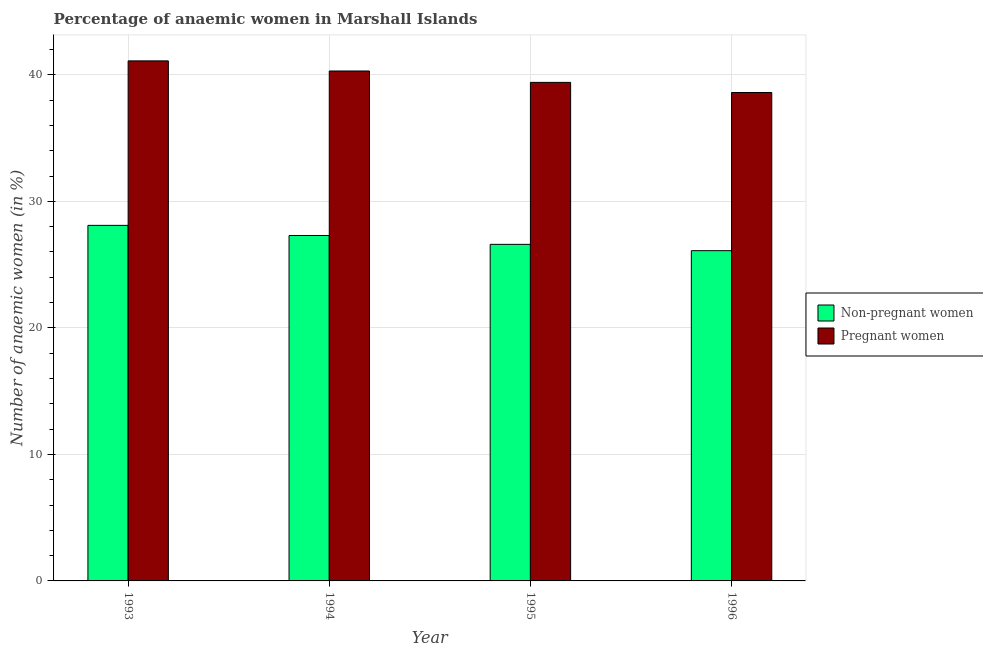Are the number of bars per tick equal to the number of legend labels?
Ensure brevity in your answer.  Yes. Are the number of bars on each tick of the X-axis equal?
Keep it short and to the point. Yes. How many bars are there on the 3rd tick from the left?
Offer a very short reply. 2. What is the label of the 3rd group of bars from the left?
Your response must be concise. 1995. In how many cases, is the number of bars for a given year not equal to the number of legend labels?
Provide a short and direct response. 0. What is the percentage of non-pregnant anaemic women in 1996?
Your answer should be compact. 26.1. Across all years, what is the maximum percentage of pregnant anaemic women?
Provide a succinct answer. 41.1. Across all years, what is the minimum percentage of non-pregnant anaemic women?
Provide a short and direct response. 26.1. What is the total percentage of pregnant anaemic women in the graph?
Provide a short and direct response. 159.4. What is the difference between the percentage of non-pregnant anaemic women in 1994 and that in 1995?
Make the answer very short. 0.7. What is the average percentage of non-pregnant anaemic women per year?
Give a very brief answer. 27.02. In how many years, is the percentage of pregnant anaemic women greater than 6 %?
Provide a short and direct response. 4. What is the ratio of the percentage of pregnant anaemic women in 1993 to that in 1994?
Your answer should be very brief. 1.02. Is the difference between the percentage of non-pregnant anaemic women in 1993 and 1994 greater than the difference between the percentage of pregnant anaemic women in 1993 and 1994?
Ensure brevity in your answer.  No. What is the difference between the highest and the second highest percentage of non-pregnant anaemic women?
Your response must be concise. 0.8. What is the difference between the highest and the lowest percentage of pregnant anaemic women?
Your response must be concise. 2.5. In how many years, is the percentage of pregnant anaemic women greater than the average percentage of pregnant anaemic women taken over all years?
Your answer should be compact. 2. Is the sum of the percentage of pregnant anaemic women in 1994 and 1995 greater than the maximum percentage of non-pregnant anaemic women across all years?
Your response must be concise. Yes. What does the 1st bar from the left in 1993 represents?
Provide a succinct answer. Non-pregnant women. What does the 2nd bar from the right in 1993 represents?
Provide a short and direct response. Non-pregnant women. How many years are there in the graph?
Provide a succinct answer. 4. Are the values on the major ticks of Y-axis written in scientific E-notation?
Provide a succinct answer. No. Does the graph contain grids?
Your answer should be compact. Yes. What is the title of the graph?
Offer a very short reply. Percentage of anaemic women in Marshall Islands. What is the label or title of the Y-axis?
Your response must be concise. Number of anaemic women (in %). What is the Number of anaemic women (in %) of Non-pregnant women in 1993?
Give a very brief answer. 28.1. What is the Number of anaemic women (in %) in Pregnant women in 1993?
Offer a terse response. 41.1. What is the Number of anaemic women (in %) in Non-pregnant women in 1994?
Offer a terse response. 27.3. What is the Number of anaemic women (in %) of Pregnant women in 1994?
Keep it short and to the point. 40.3. What is the Number of anaemic women (in %) of Non-pregnant women in 1995?
Give a very brief answer. 26.6. What is the Number of anaemic women (in %) in Pregnant women in 1995?
Provide a short and direct response. 39.4. What is the Number of anaemic women (in %) in Non-pregnant women in 1996?
Keep it short and to the point. 26.1. What is the Number of anaemic women (in %) of Pregnant women in 1996?
Offer a terse response. 38.6. Across all years, what is the maximum Number of anaemic women (in %) in Non-pregnant women?
Your answer should be very brief. 28.1. Across all years, what is the maximum Number of anaemic women (in %) of Pregnant women?
Your answer should be compact. 41.1. Across all years, what is the minimum Number of anaemic women (in %) of Non-pregnant women?
Your answer should be compact. 26.1. Across all years, what is the minimum Number of anaemic women (in %) in Pregnant women?
Your answer should be very brief. 38.6. What is the total Number of anaemic women (in %) in Non-pregnant women in the graph?
Offer a terse response. 108.1. What is the total Number of anaemic women (in %) in Pregnant women in the graph?
Provide a short and direct response. 159.4. What is the difference between the Number of anaemic women (in %) in Non-pregnant women in 1993 and that in 1994?
Give a very brief answer. 0.8. What is the difference between the Number of anaemic women (in %) of Pregnant women in 1993 and that in 1994?
Your answer should be compact. 0.8. What is the difference between the Number of anaemic women (in %) of Non-pregnant women in 1993 and that in 1996?
Offer a terse response. 2. What is the difference between the Number of anaemic women (in %) of Non-pregnant women in 1995 and that in 1996?
Keep it short and to the point. 0.5. What is the difference between the Number of anaemic women (in %) of Non-pregnant women in 1993 and the Number of anaemic women (in %) of Pregnant women in 1995?
Your response must be concise. -11.3. What is the difference between the Number of anaemic women (in %) in Non-pregnant women in 1994 and the Number of anaemic women (in %) in Pregnant women in 1995?
Your answer should be very brief. -12.1. What is the difference between the Number of anaemic women (in %) in Non-pregnant women in 1994 and the Number of anaemic women (in %) in Pregnant women in 1996?
Offer a terse response. -11.3. What is the average Number of anaemic women (in %) in Non-pregnant women per year?
Ensure brevity in your answer.  27.02. What is the average Number of anaemic women (in %) of Pregnant women per year?
Offer a terse response. 39.85. In the year 1993, what is the difference between the Number of anaemic women (in %) of Non-pregnant women and Number of anaemic women (in %) of Pregnant women?
Your answer should be very brief. -13. In the year 1994, what is the difference between the Number of anaemic women (in %) of Non-pregnant women and Number of anaemic women (in %) of Pregnant women?
Ensure brevity in your answer.  -13. In the year 1995, what is the difference between the Number of anaemic women (in %) of Non-pregnant women and Number of anaemic women (in %) of Pregnant women?
Ensure brevity in your answer.  -12.8. What is the ratio of the Number of anaemic women (in %) in Non-pregnant women in 1993 to that in 1994?
Provide a short and direct response. 1.03. What is the ratio of the Number of anaemic women (in %) of Pregnant women in 1993 to that in 1994?
Your answer should be very brief. 1.02. What is the ratio of the Number of anaemic women (in %) of Non-pregnant women in 1993 to that in 1995?
Your answer should be very brief. 1.06. What is the ratio of the Number of anaemic women (in %) of Pregnant women in 1993 to that in 1995?
Your answer should be compact. 1.04. What is the ratio of the Number of anaemic women (in %) in Non-pregnant women in 1993 to that in 1996?
Offer a very short reply. 1.08. What is the ratio of the Number of anaemic women (in %) in Pregnant women in 1993 to that in 1996?
Your answer should be very brief. 1.06. What is the ratio of the Number of anaemic women (in %) in Non-pregnant women in 1994 to that in 1995?
Your answer should be compact. 1.03. What is the ratio of the Number of anaemic women (in %) in Pregnant women in 1994 to that in 1995?
Make the answer very short. 1.02. What is the ratio of the Number of anaemic women (in %) of Non-pregnant women in 1994 to that in 1996?
Keep it short and to the point. 1.05. What is the ratio of the Number of anaemic women (in %) of Pregnant women in 1994 to that in 1996?
Provide a succinct answer. 1.04. What is the ratio of the Number of anaemic women (in %) in Non-pregnant women in 1995 to that in 1996?
Provide a succinct answer. 1.02. What is the ratio of the Number of anaemic women (in %) in Pregnant women in 1995 to that in 1996?
Give a very brief answer. 1.02. What is the difference between the highest and the second highest Number of anaemic women (in %) of Non-pregnant women?
Give a very brief answer. 0.8. What is the difference between the highest and the second highest Number of anaemic women (in %) in Pregnant women?
Offer a terse response. 0.8. What is the difference between the highest and the lowest Number of anaemic women (in %) of Non-pregnant women?
Your response must be concise. 2. What is the difference between the highest and the lowest Number of anaemic women (in %) in Pregnant women?
Your response must be concise. 2.5. 